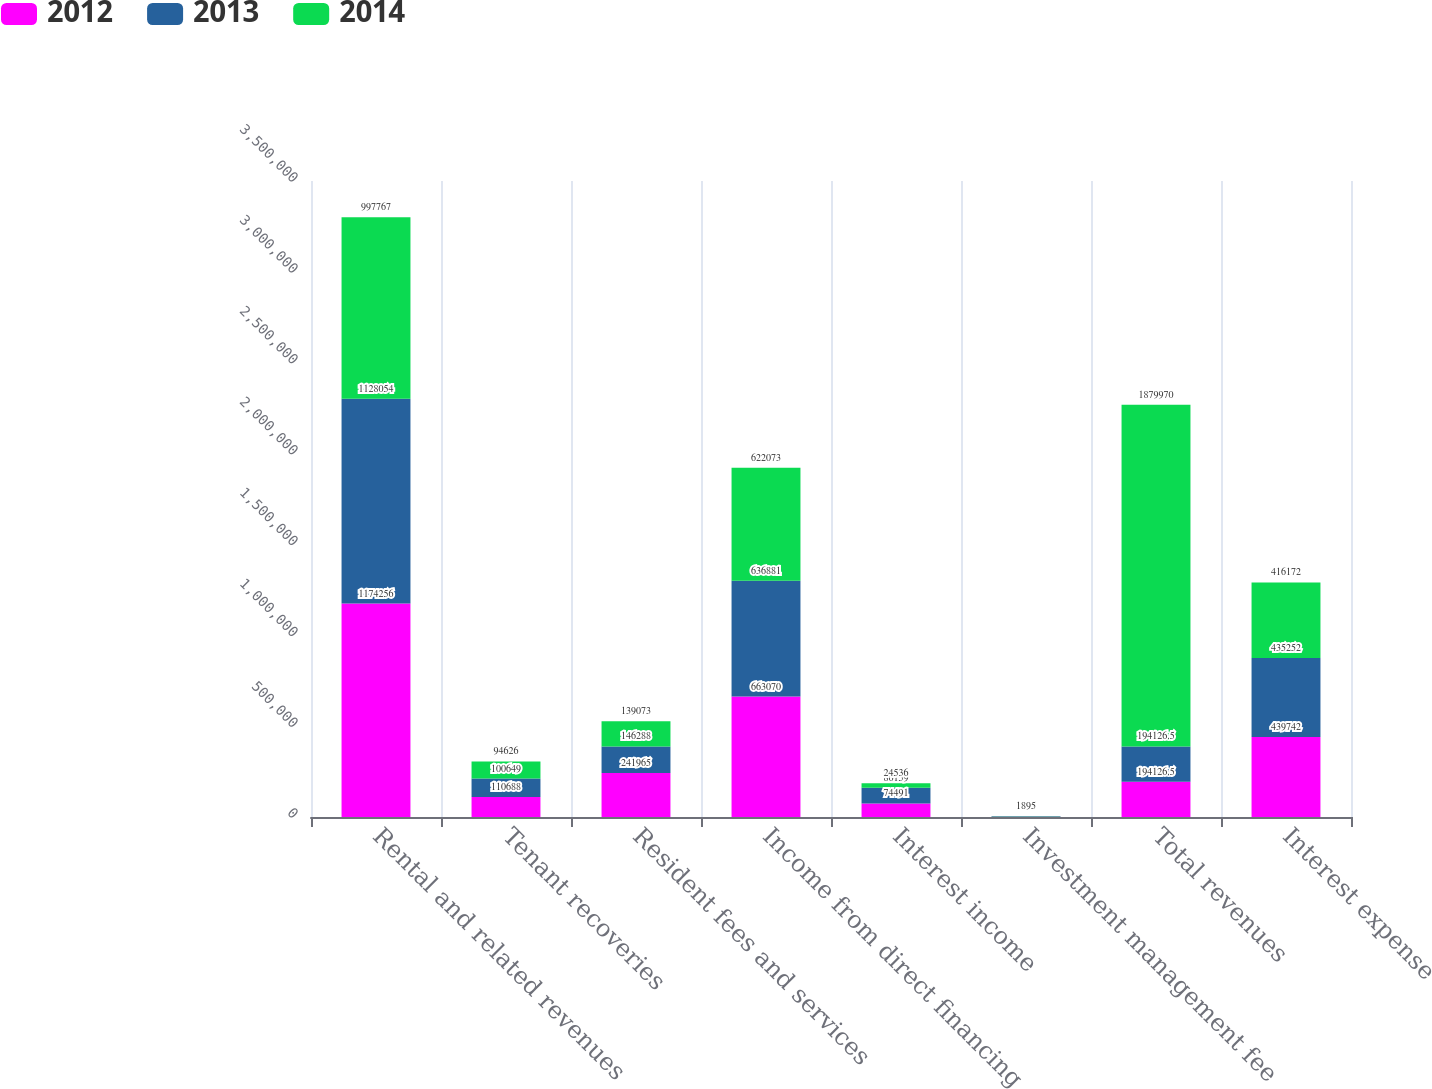Convert chart to OTSL. <chart><loc_0><loc_0><loc_500><loc_500><stacked_bar_chart><ecel><fcel>Rental and related revenues<fcel>Tenant recoveries<fcel>Resident fees and services<fcel>Income from direct financing<fcel>Interest income<fcel>Investment management fee<fcel>Total revenues<fcel>Interest expense<nl><fcel>2012<fcel>1.17426e+06<fcel>110688<fcel>241965<fcel>663070<fcel>74491<fcel>1809<fcel>194126<fcel>439742<nl><fcel>2013<fcel>1.12805e+06<fcel>100649<fcel>146288<fcel>636881<fcel>86159<fcel>1847<fcel>194126<fcel>435252<nl><fcel>2014<fcel>997767<fcel>94626<fcel>139073<fcel>622073<fcel>24536<fcel>1895<fcel>1.87997e+06<fcel>416172<nl></chart> 